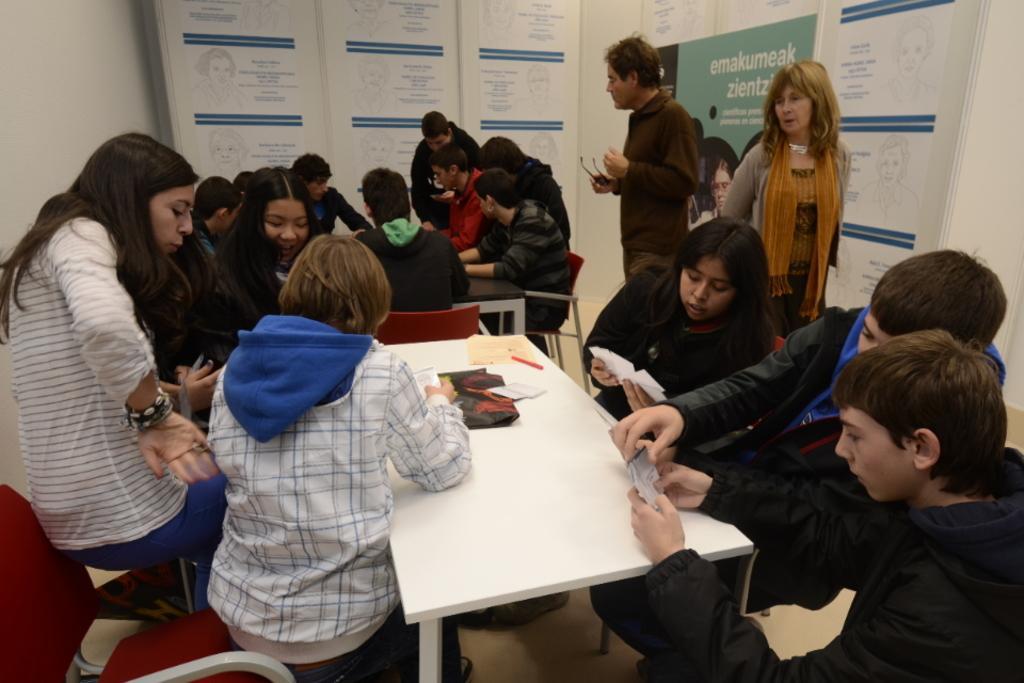Can you describe this image briefly? Here we can see group of people sitting on chairs with tables in front of them and everybody is discussing something with themselves and there are couple of people standing and there are banners on the walls present 